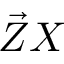<formula> <loc_0><loc_0><loc_500><loc_500>\vec { Z } X</formula> 